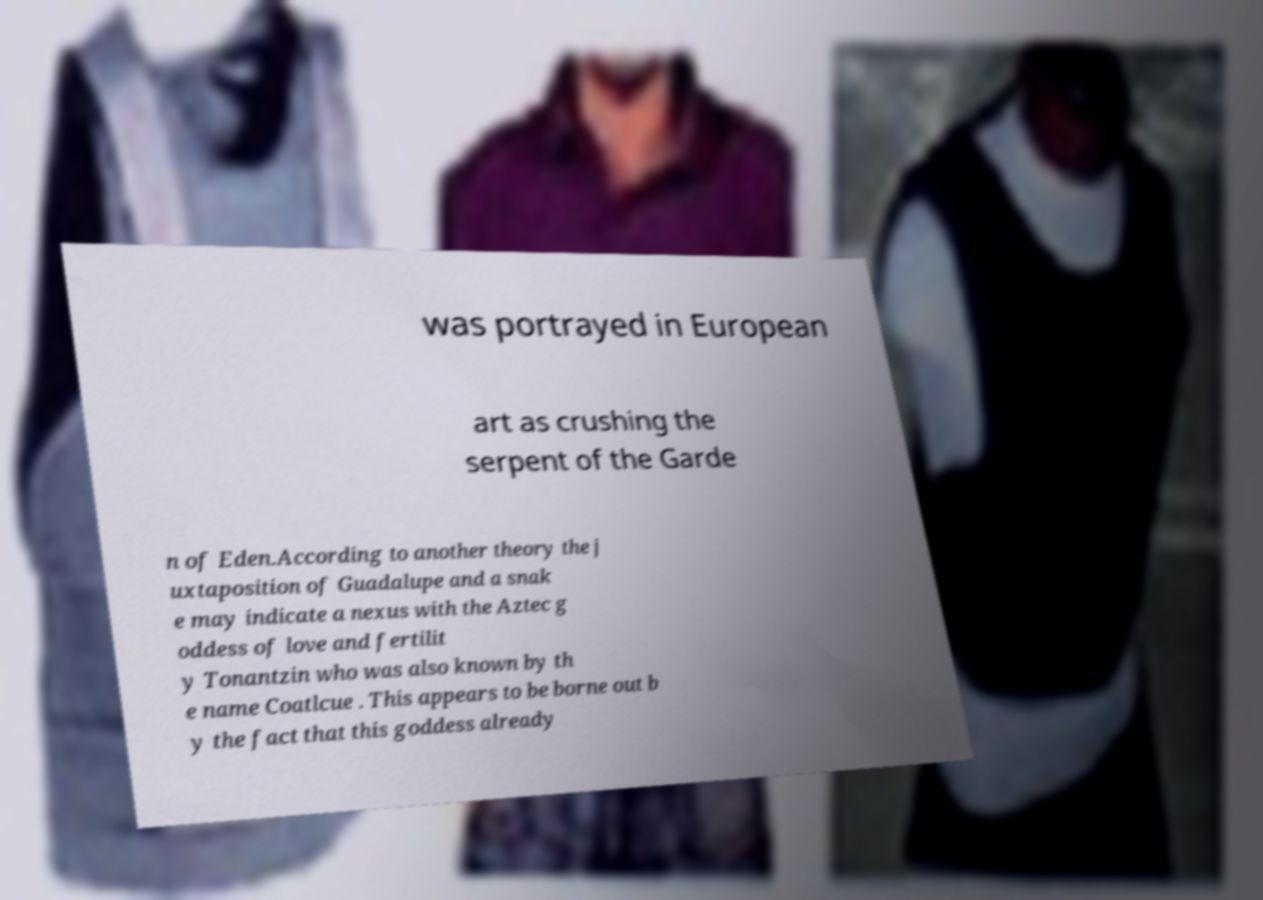Could you extract and type out the text from this image? was portrayed in European art as crushing the serpent of the Garde n of Eden.According to another theory the j uxtaposition of Guadalupe and a snak e may indicate a nexus with the Aztec g oddess of love and fertilit y Tonantzin who was also known by th e name Coatlcue . This appears to be borne out b y the fact that this goddess already 